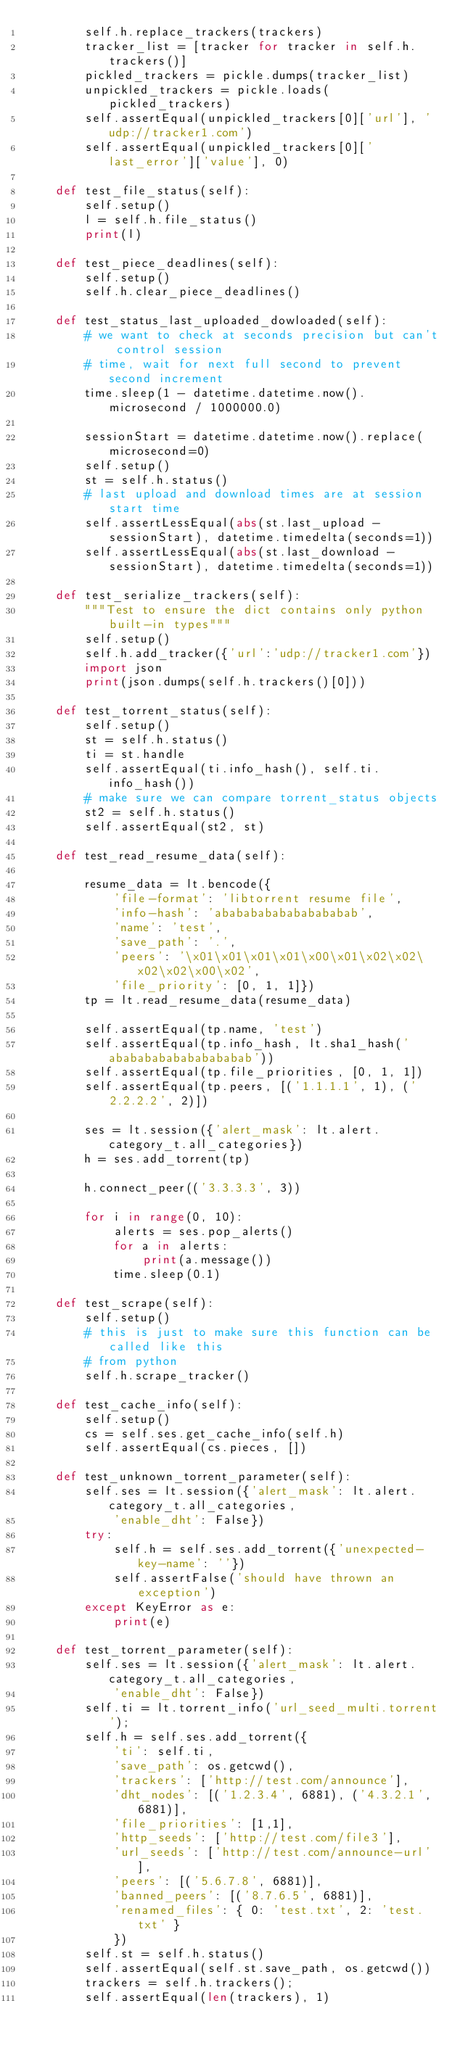Convert code to text. <code><loc_0><loc_0><loc_500><loc_500><_Python_>        self.h.replace_trackers(trackers)
        tracker_list = [tracker for tracker in self.h.trackers()]
        pickled_trackers = pickle.dumps(tracker_list)
        unpickled_trackers = pickle.loads(pickled_trackers)
        self.assertEqual(unpickled_trackers[0]['url'], 'udp://tracker1.com')
        self.assertEqual(unpickled_trackers[0]['last_error']['value'], 0)

    def test_file_status(self):
        self.setup()
        l = self.h.file_status()
        print(l)

    def test_piece_deadlines(self):
        self.setup()
        self.h.clear_piece_deadlines()

    def test_status_last_uploaded_dowloaded(self):
        # we want to check at seconds precision but can't control session
        # time, wait for next full second to prevent second increment
        time.sleep(1 - datetime.datetime.now().microsecond / 1000000.0)

        sessionStart = datetime.datetime.now().replace(microsecond=0)
        self.setup()
        st = self.h.status()
        # last upload and download times are at session start time
        self.assertLessEqual(abs(st.last_upload - sessionStart), datetime.timedelta(seconds=1))
        self.assertLessEqual(abs(st.last_download - sessionStart), datetime.timedelta(seconds=1))

    def test_serialize_trackers(self):
        """Test to ensure the dict contains only python built-in types"""
        self.setup()
        self.h.add_tracker({'url':'udp://tracker1.com'})
        import json
        print(json.dumps(self.h.trackers()[0]))

    def test_torrent_status(self):
        self.setup()
        st = self.h.status()
        ti = st.handle
        self.assertEqual(ti.info_hash(), self.ti.info_hash())
        # make sure we can compare torrent_status objects
        st2 = self.h.status()
        self.assertEqual(st2, st)

    def test_read_resume_data(self):

        resume_data = lt.bencode({
            'file-format': 'libtorrent resume file',
            'info-hash': 'abababababababababab',
            'name': 'test',
            'save_path': '.',
            'peers': '\x01\x01\x01\x01\x00\x01\x02\x02\x02\x02\x00\x02',
            'file_priority': [0, 1, 1]})
        tp = lt.read_resume_data(resume_data)

        self.assertEqual(tp.name, 'test')
        self.assertEqual(tp.info_hash, lt.sha1_hash('abababababababababab'))
        self.assertEqual(tp.file_priorities, [0, 1, 1])
        self.assertEqual(tp.peers, [('1.1.1.1', 1), ('2.2.2.2', 2)])

        ses = lt.session({'alert_mask': lt.alert.category_t.all_categories})
        h = ses.add_torrent(tp)

        h.connect_peer(('3.3.3.3', 3))

        for i in range(0, 10):
            alerts = ses.pop_alerts()
            for a in alerts:
                print(a.message())
            time.sleep(0.1)

    def test_scrape(self):
        self.setup()
        # this is just to make sure this function can be called like this
        # from python
        self.h.scrape_tracker()

    def test_cache_info(self):
        self.setup()
        cs = self.ses.get_cache_info(self.h)
        self.assertEqual(cs.pieces, [])

    def test_unknown_torrent_parameter(self):
        self.ses = lt.session({'alert_mask': lt.alert.category_t.all_categories,
            'enable_dht': False})
        try:
            self.h = self.ses.add_torrent({'unexpected-key-name': ''})
            self.assertFalse('should have thrown an exception')
        except KeyError as e:
            print(e)

    def test_torrent_parameter(self):
        self.ses = lt.session({'alert_mask': lt.alert.category_t.all_categories,
            'enable_dht': False})
        self.ti = lt.torrent_info('url_seed_multi.torrent');
        self.h = self.ses.add_torrent({
            'ti': self.ti,
            'save_path': os.getcwd(),
            'trackers': ['http://test.com/announce'],
            'dht_nodes': [('1.2.3.4', 6881), ('4.3.2.1', 6881)],
            'file_priorities': [1,1],
            'http_seeds': ['http://test.com/file3'],
            'url_seeds': ['http://test.com/announce-url'],
            'peers': [('5.6.7.8', 6881)],
            'banned_peers': [('8.7.6.5', 6881)],
            'renamed_files': { 0: 'test.txt', 2: 'test.txt' }
            })
        self.st = self.h.status()
        self.assertEqual(self.st.save_path, os.getcwd())
        trackers = self.h.trackers();
        self.assertEqual(len(trackers), 1)</code> 